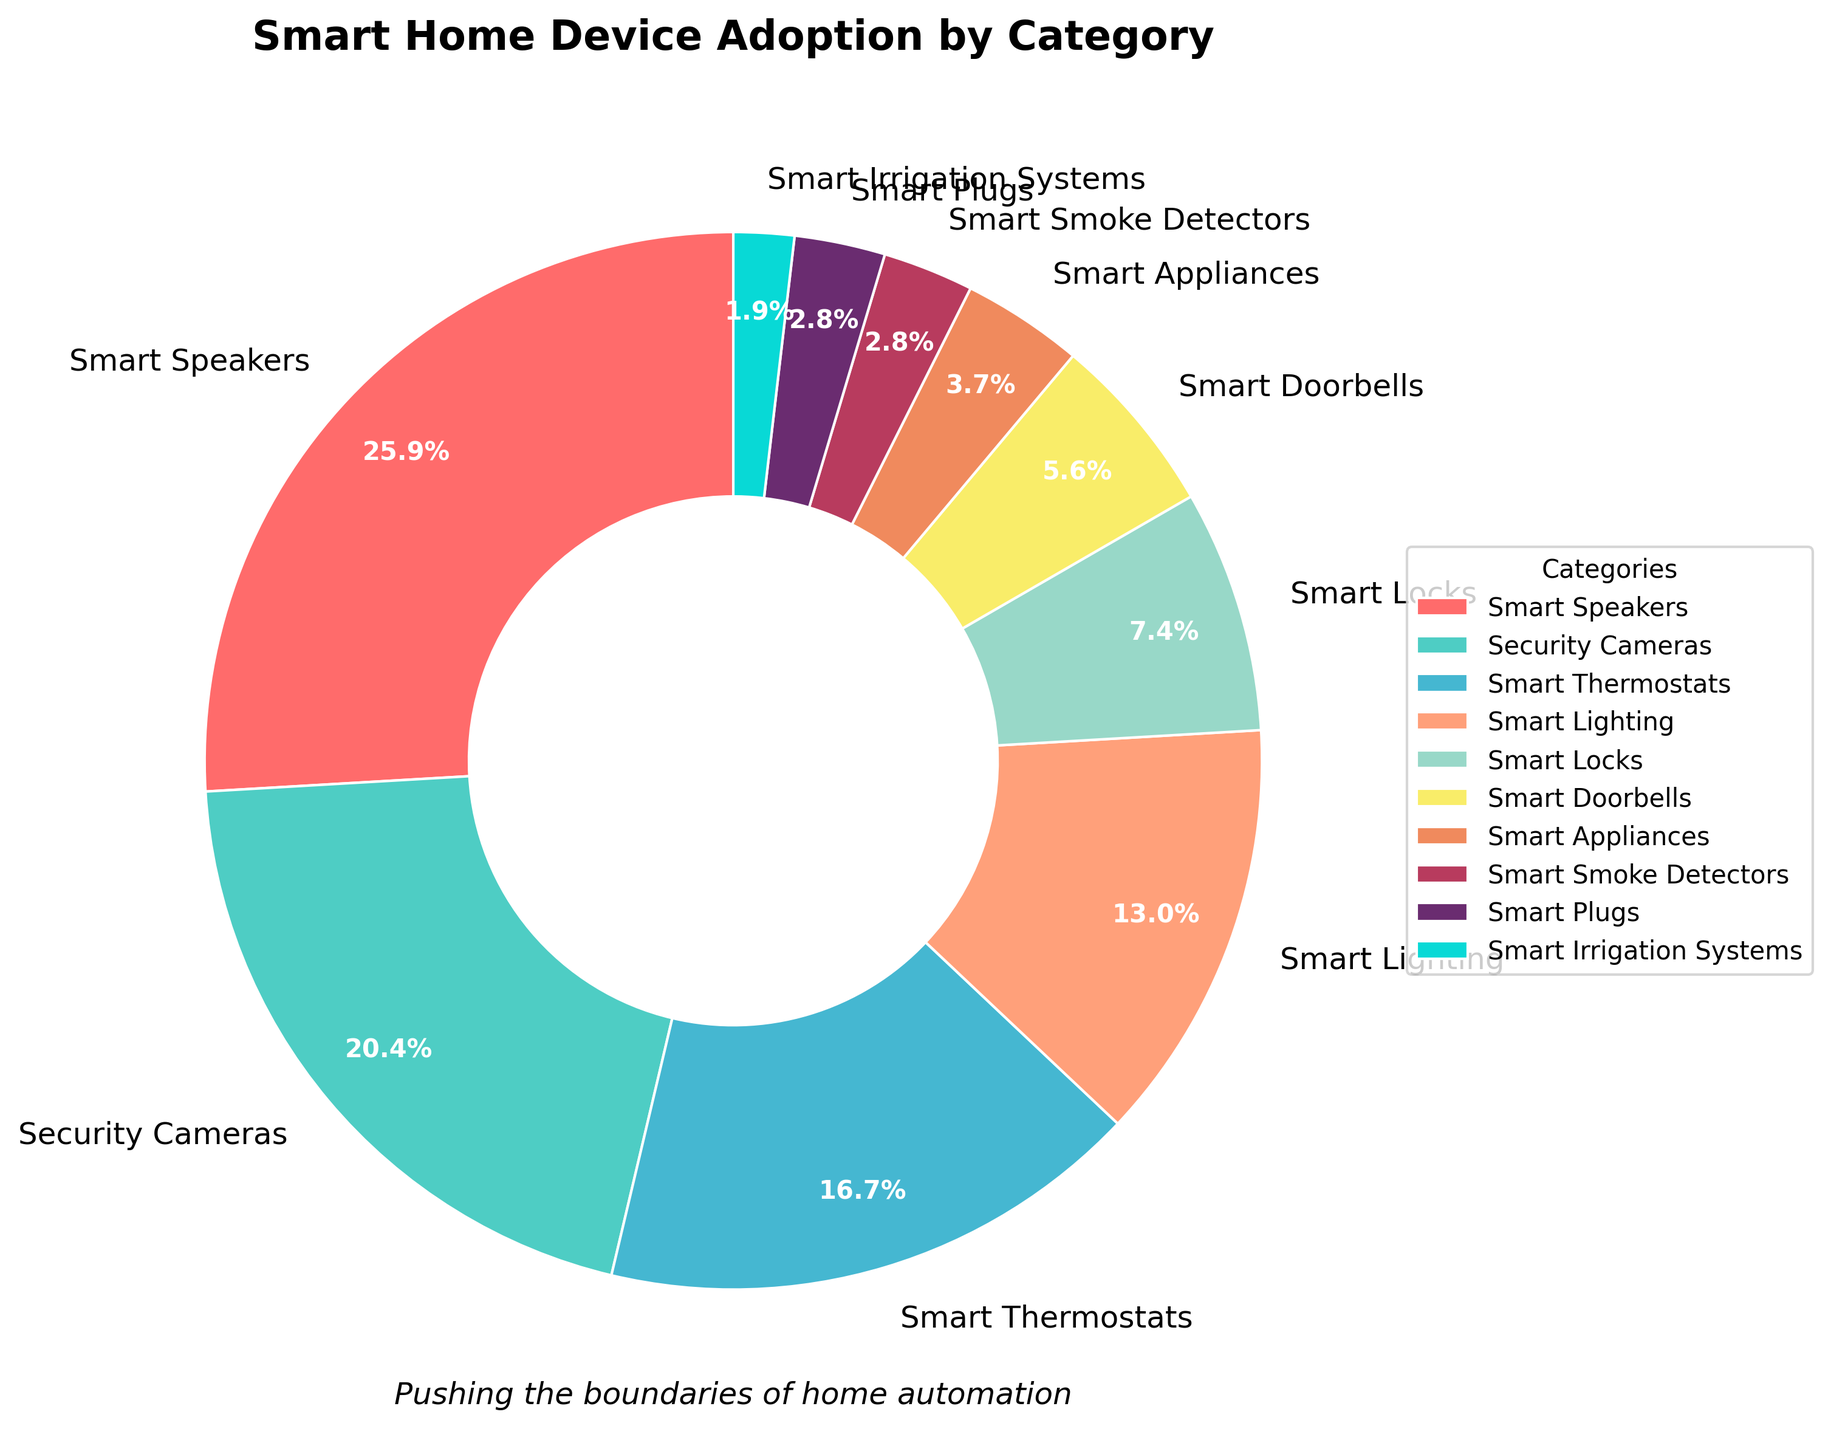Which category has the highest adoption percentage? The category with the highest adoption percentage is visually represented by the largest slice of the pie chart. By examining the chart, we observe that the "Smart Speakers" segment is the largest.
Answer: Smart Speakers What is the percentage difference between Security Cameras and Smart Appliances? First, identify the percentages for Security Cameras (22%) and Smart Appliances (4%) from the chart. Subtract the smaller percentage from the larger one: 22% - 4% = 18%.
Answer: 18% How does the adoption of Smart Thermostats compare to Smart Lighting? Find the percentages for Smart Thermostats (18%) and Smart Lighting (14%) on the chart. Compare the two values: 18% is higher than 14%.
Answer: Smart Thermostats have higher adoption What is the total percentage for Smart Locks, Smart Doorbells, and Smart Appliances combined? From the chart, find the percentages for Smart Locks (8%), Smart Doorbells (6%), and Smart Appliances (4%). Sum these percentages: 8% + 6% + 4% = 18%.
Answer: 18% Which category occupies the smallest slice of the pie chart? Examine the pie chart to identify the smallest slice, which corresponds to the lowest percentage. The "Smart Irrigation Systems" slice is the smallest at 2%.
Answer: Smart Irrigation Systems Are Smart Speakers and Security Cameras adoption percentages collectively greater than 50%? Sum the percentages for Smart Speakers (28%) and Security Cameras (22%): 28% + 22% = 50%. Since the question asks if this sum is greater than 50%, the answer is no.
Answer: No What is the average adoption percentage of the categories shown in the chart? Sum all the listed percentages: 28% + 22% + 18% + 14% + 8% + 6% + 4% + 3% + 3% + 2% = 108%. Divide by the number of categories (10): 108% / 10 = 10.8%.
Answer: 10.8% Which color represents Smart Thermostats in the pie chart? Locate the "Smart Thermostats" label in the pie chart and identify the color of the corresponding slice. From the data and color assignments, Smart Thermostats are represented in blue.
Answer: Blue What is the combined adoption percentage of Smart Plugs and Smart Smoke Detectors? Identify the percentages for Smart Plugs (3%) and Smart Smoke Detectors (3%). Sum these percentages: 3% + 3% = 6%.
Answer: 6% 